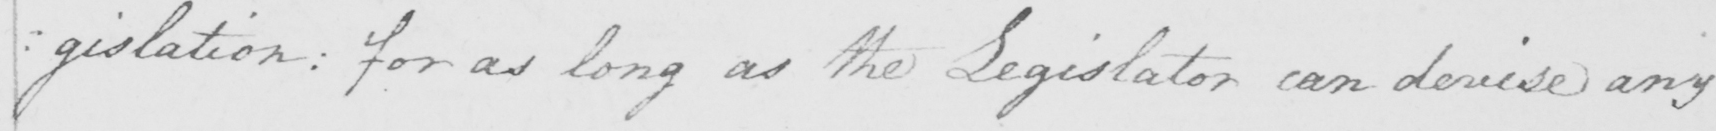Transcribe the text shown in this historical manuscript line. :gislation: for as long as the Legislator can devise any 